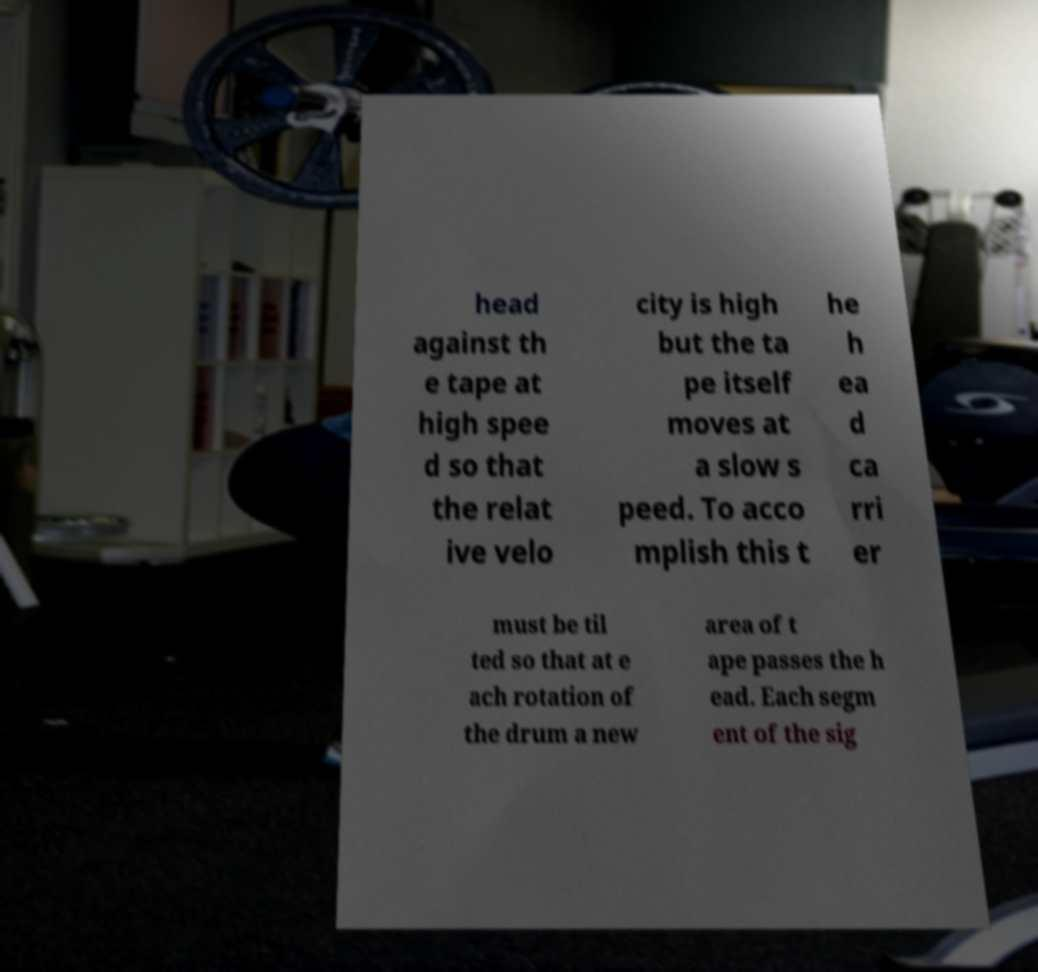What messages or text are displayed in this image? I need them in a readable, typed format. head against th e tape at high spee d so that the relat ive velo city is high but the ta pe itself moves at a slow s peed. To acco mplish this t he h ea d ca rri er must be til ted so that at e ach rotation of the drum a new area of t ape passes the h ead. Each segm ent of the sig 